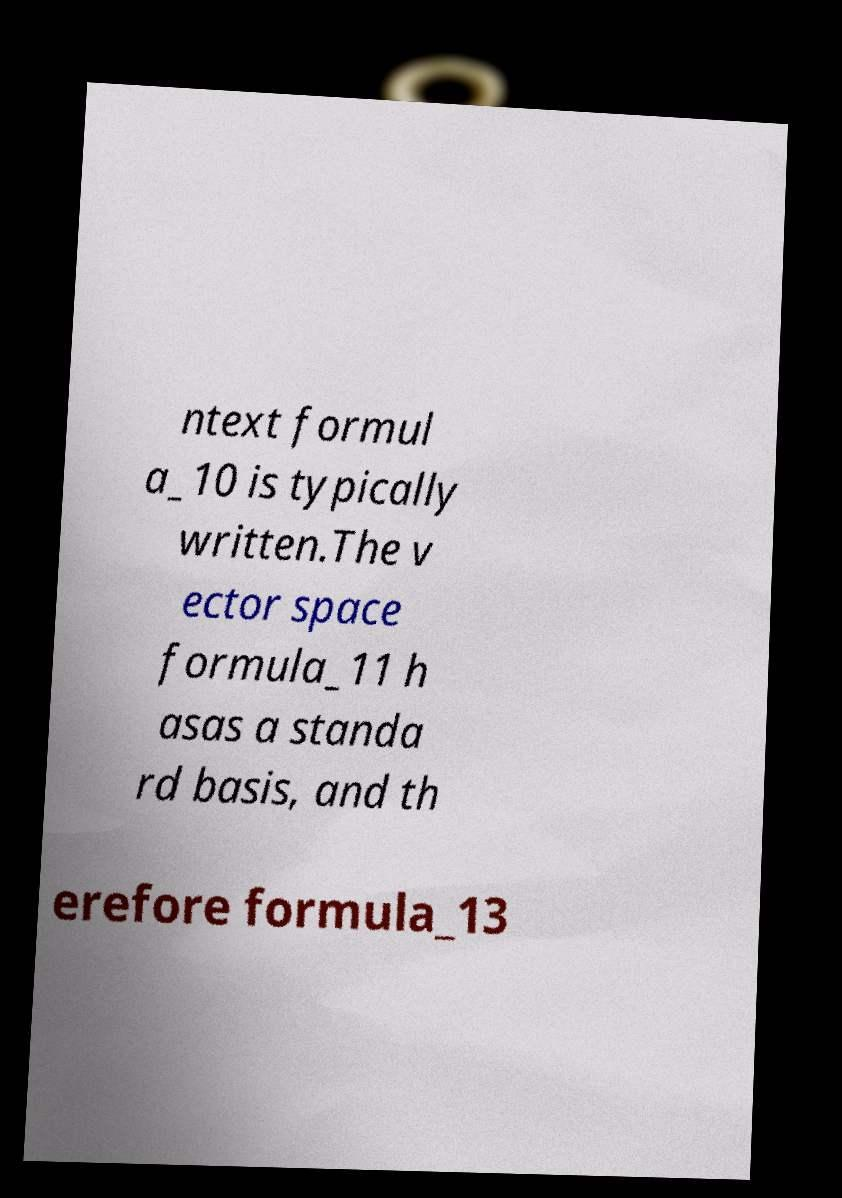For documentation purposes, I need the text within this image transcribed. Could you provide that? ntext formul a_10 is typically written.The v ector space formula_11 h asas a standa rd basis, and th erefore formula_13 